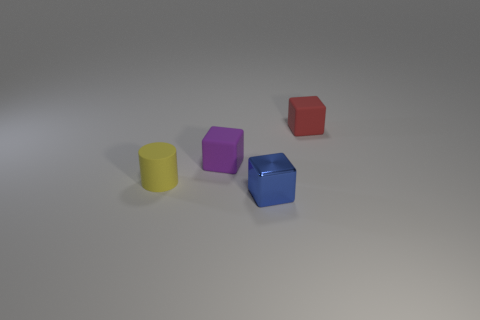If I were to arrange these objects by volume, from smallest to largest, what would the order be? Based on visual estimation, the order from smallest to largest volume would likely be: the yellow cylinder, the green sphere (as it is partly hidden), the purple cube, the red cube, and lastly, the blue hexagonal prism. 